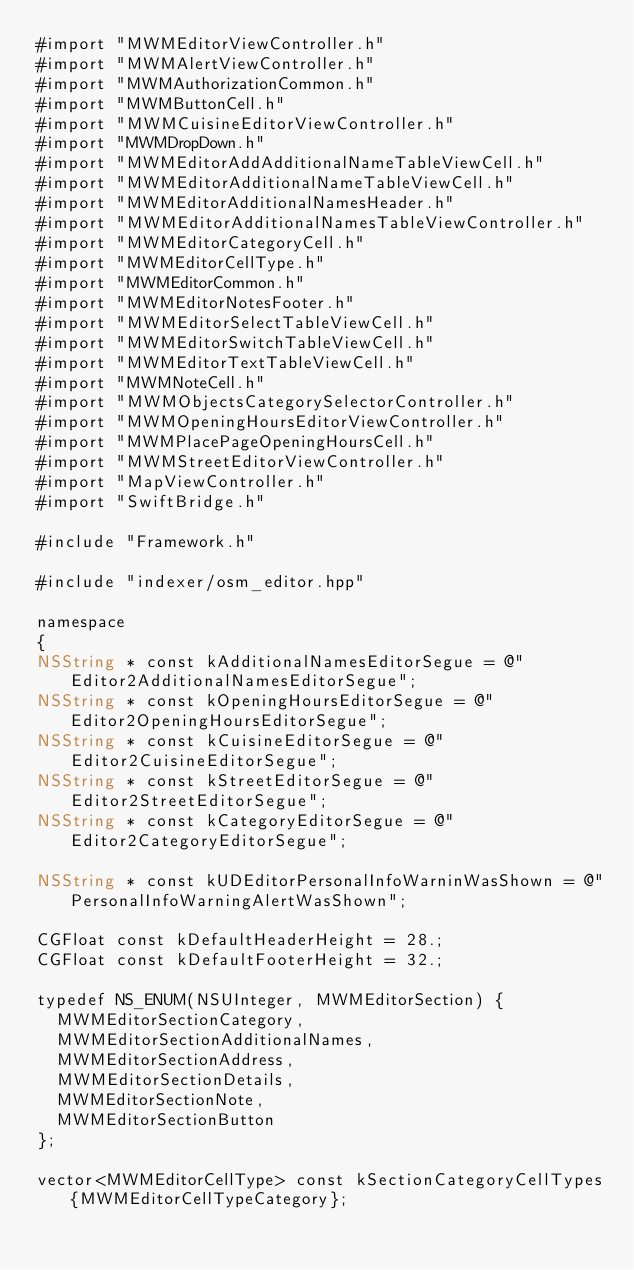<code> <loc_0><loc_0><loc_500><loc_500><_ObjectiveC_>#import "MWMEditorViewController.h"
#import "MWMAlertViewController.h"
#import "MWMAuthorizationCommon.h"
#import "MWMButtonCell.h"
#import "MWMCuisineEditorViewController.h"
#import "MWMDropDown.h"
#import "MWMEditorAddAdditionalNameTableViewCell.h"
#import "MWMEditorAdditionalNameTableViewCell.h"
#import "MWMEditorAdditionalNamesHeader.h"
#import "MWMEditorAdditionalNamesTableViewController.h"
#import "MWMEditorCategoryCell.h"
#import "MWMEditorCellType.h"
#import "MWMEditorCommon.h"
#import "MWMEditorNotesFooter.h"
#import "MWMEditorSelectTableViewCell.h"
#import "MWMEditorSwitchTableViewCell.h"
#import "MWMEditorTextTableViewCell.h"
#import "MWMNoteCell.h"
#import "MWMObjectsCategorySelectorController.h"
#import "MWMOpeningHoursEditorViewController.h"
#import "MWMPlacePageOpeningHoursCell.h"
#import "MWMStreetEditorViewController.h"
#import "MapViewController.h"
#import "SwiftBridge.h"

#include "Framework.h"

#include "indexer/osm_editor.hpp"

namespace
{
NSString * const kAdditionalNamesEditorSegue = @"Editor2AdditionalNamesEditorSegue";
NSString * const kOpeningHoursEditorSegue = @"Editor2OpeningHoursEditorSegue";
NSString * const kCuisineEditorSegue = @"Editor2CuisineEditorSegue";
NSString * const kStreetEditorSegue = @"Editor2StreetEditorSegue";
NSString * const kCategoryEditorSegue = @"Editor2CategoryEditorSegue";

NSString * const kUDEditorPersonalInfoWarninWasShown = @"PersonalInfoWarningAlertWasShown";

CGFloat const kDefaultHeaderHeight = 28.;
CGFloat const kDefaultFooterHeight = 32.;

typedef NS_ENUM(NSUInteger, MWMEditorSection) {
  MWMEditorSectionCategory,
  MWMEditorSectionAdditionalNames,
  MWMEditorSectionAddress,
  MWMEditorSectionDetails,
  MWMEditorSectionNote,
  MWMEditorSectionButton
};

vector<MWMEditorCellType> const kSectionCategoryCellTypes{MWMEditorCellTypeCategory};</code> 